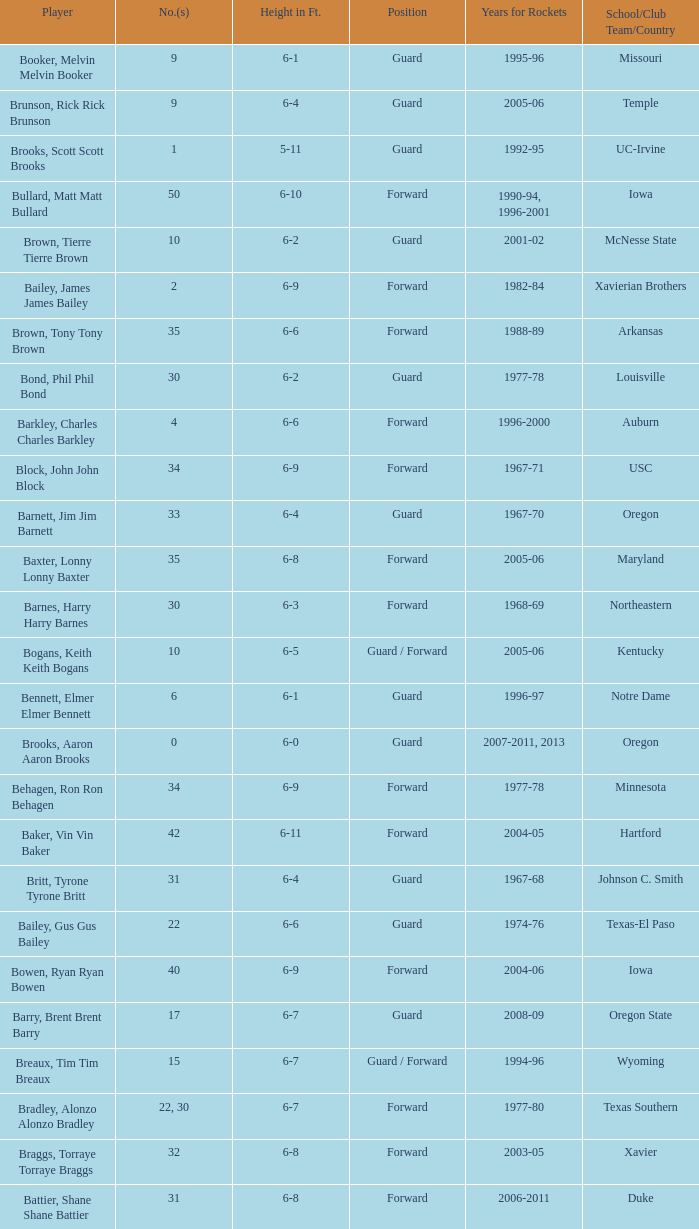Write the full table. {'header': ['Player', 'No.(s)', 'Height in Ft.', 'Position', 'Years for Rockets', 'School/Club Team/Country'], 'rows': [['Booker, Melvin Melvin Booker', '9', '6-1', 'Guard', '1995-96', 'Missouri'], ['Brunson, Rick Rick Brunson', '9', '6-4', 'Guard', '2005-06', 'Temple'], ['Brooks, Scott Scott Brooks', '1', '5-11', 'Guard', '1992-95', 'UC-Irvine'], ['Bullard, Matt Matt Bullard', '50', '6-10', 'Forward', '1990-94, 1996-2001', 'Iowa'], ['Brown, Tierre Tierre Brown', '10', '6-2', 'Guard', '2001-02', 'McNesse State'], ['Bailey, James James Bailey', '2', '6-9', 'Forward', '1982-84', 'Xavierian Brothers'], ['Brown, Tony Tony Brown', '35', '6-6', 'Forward', '1988-89', 'Arkansas'], ['Bond, Phil Phil Bond', '30', '6-2', 'Guard', '1977-78', 'Louisville'], ['Barkley, Charles Charles Barkley', '4', '6-6', 'Forward', '1996-2000', 'Auburn'], ['Block, John John Block', '34', '6-9', 'Forward', '1967-71', 'USC'], ['Barnett, Jim Jim Barnett', '33', '6-4', 'Guard', '1967-70', 'Oregon'], ['Baxter, Lonny Lonny Baxter', '35', '6-8', 'Forward', '2005-06', 'Maryland'], ['Barnes, Harry Harry Barnes', '30', '6-3', 'Forward', '1968-69', 'Northeastern'], ['Bogans, Keith Keith Bogans', '10', '6-5', 'Guard / Forward', '2005-06', 'Kentucky'], ['Bennett, Elmer Elmer Bennett', '6', '6-1', 'Guard', '1996-97', 'Notre Dame'], ['Brooks, Aaron Aaron Brooks', '0', '6-0', 'Guard', '2007-2011, 2013', 'Oregon'], ['Behagen, Ron Ron Behagen', '34', '6-9', 'Forward', '1977-78', 'Minnesota'], ['Baker, Vin Vin Baker', '42', '6-11', 'Forward', '2004-05', 'Hartford'], ['Britt, Tyrone Tyrone Britt', '31', '6-4', 'Guard', '1967-68', 'Johnson C. Smith'], ['Bailey, Gus Gus Bailey', '22', '6-6', 'Guard', '1974-76', 'Texas-El Paso'], ['Bowen, Ryan Ryan Bowen', '40', '6-9', 'Forward', '2004-06', 'Iowa'], ['Barry, Brent Brent Barry', '17', '6-7', 'Guard', '2008-09', 'Oregon State'], ['Breaux, Tim Tim Breaux', '15', '6-7', 'Guard / Forward', '1994-96', 'Wyoming'], ['Bradley, Alonzo Alonzo Bradley', '22, 30', '6-7', 'Forward', '1977-80', 'Texas Southern'], ['Braggs, Torraye Torraye Braggs', '32', '6-8', 'Forward', '2003-05', 'Xavier'], ['Battier, Shane Shane Battier', '31', '6-8', 'Forward', '2006-2011', 'Duke'], ['Barnhill, John John Barnhill', '30', '6-1', 'Guard', '1967-68', 'Tennessee State'], ['Berry, Walter Walter Berry', '6', '6-8', 'Forward', '1988-89', 'St. Johns'], ['Barrett, Andre Andre Barrett', '12', '5-10', 'Guard', '2004-05', 'Seton Hall'], ['Bowie, Anthony Anthony Bowie', '25', '6-6', 'Guard', '1989-90', 'Oklahoma'], ['Barry, Jon Jon Barry', '20', '6-5', 'Guard', '2004-06', 'Georgia Tech'], ['Barker, Tom Tom Barker', '15', '6-11', 'Center', '1978-79', 'Hawaii'], ['Brown, Chucky Chucky Brown', '52', '6-8', 'Forward', '1994-96', 'North Carolina'], ['Bryant, Mark Mark Bryant', '2', '6-9', 'Forward', '1995-96', 'Seton Hall'], ['Budinger, Chase Chase Budinger', '10', '6-7', 'Forward', '2009-2012', 'Arizona'], ['Barry, Rick Rick Barry', '2', '6-8', 'Forward', '1978-80', 'Miami'], ['Bryant, Joe Joe Bryant', '22', '6-9', 'Forward / Guard', '1982-83', 'LaSalle']]} What is the height of the player who attended Hartford? 6-11. 